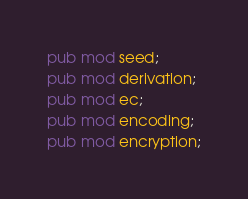<code> <loc_0><loc_0><loc_500><loc_500><_Rust_>pub mod seed;
pub mod derivation;
pub mod ec;
pub mod encoding;
pub mod encryption;</code> 